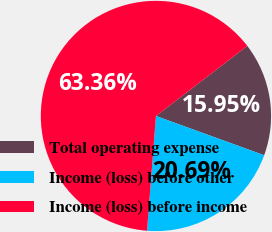<chart> <loc_0><loc_0><loc_500><loc_500><pie_chart><fcel>Total operating expense<fcel>Income (loss) before other<fcel>Income (loss) before income<nl><fcel>15.95%<fcel>20.69%<fcel>63.35%<nl></chart> 